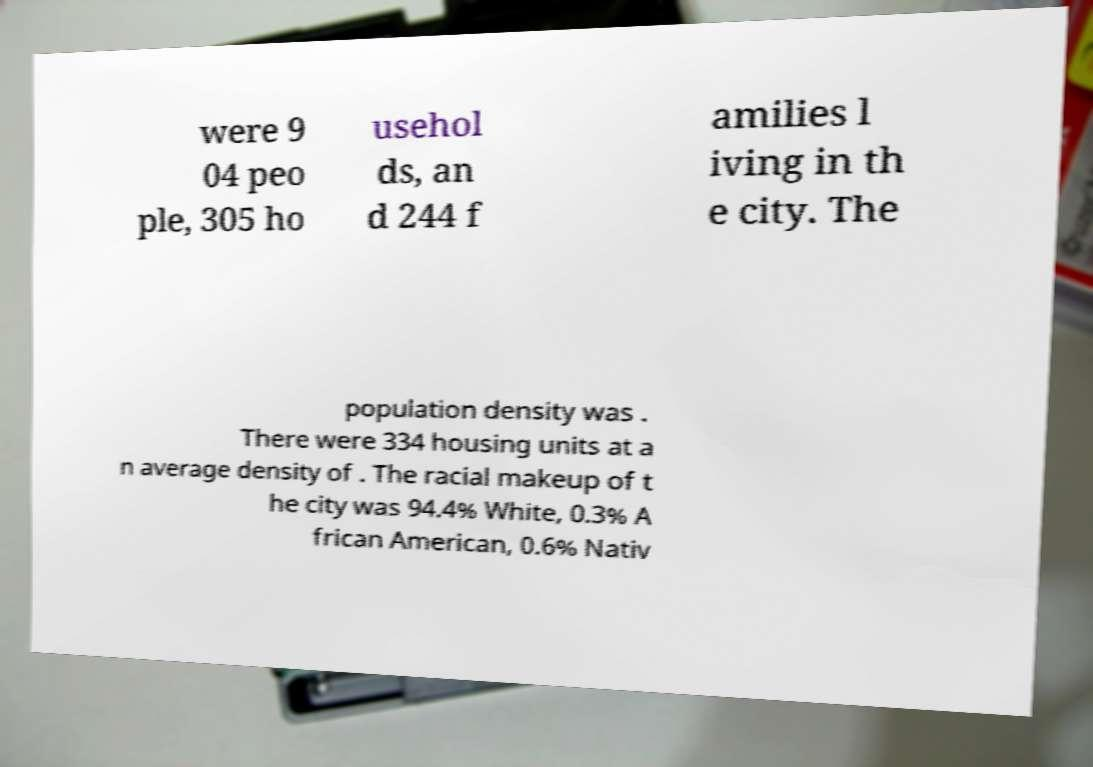Can you accurately transcribe the text from the provided image for me? were 9 04 peo ple, 305 ho usehol ds, an d 244 f amilies l iving in th e city. The population density was . There were 334 housing units at a n average density of . The racial makeup of t he city was 94.4% White, 0.3% A frican American, 0.6% Nativ 